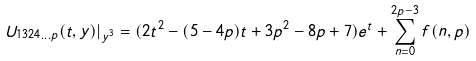Convert formula to latex. <formula><loc_0><loc_0><loc_500><loc_500>U _ { 1 3 2 4 \dots p } ( t , y ) | _ { y ^ { 3 } } = ( 2 t ^ { 2 } - ( 5 - 4 p ) t + 3 p ^ { 2 } - 8 p + 7 ) e ^ { t } + \sum _ { n = 0 } ^ { 2 p - 3 } f ( n , p )</formula> 